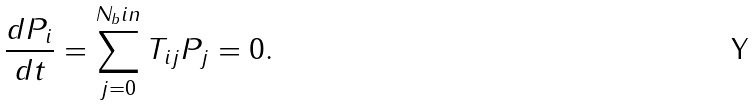<formula> <loc_0><loc_0><loc_500><loc_500>\frac { d P _ { i } } { d t } = \sum _ { j = 0 } ^ { N _ { b } i n } T _ { i j } P _ { j } = 0 .</formula> 